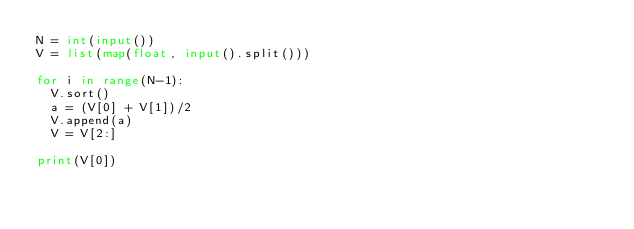<code> <loc_0><loc_0><loc_500><loc_500><_Python_>N = int(input())
V = list(map(float, input().split()))

for i in range(N-1):
  V.sort()
  a = (V[0] + V[1])/2
  V.append(a)
  V = V[2:]

print(V[0])

  
  

  </code> 